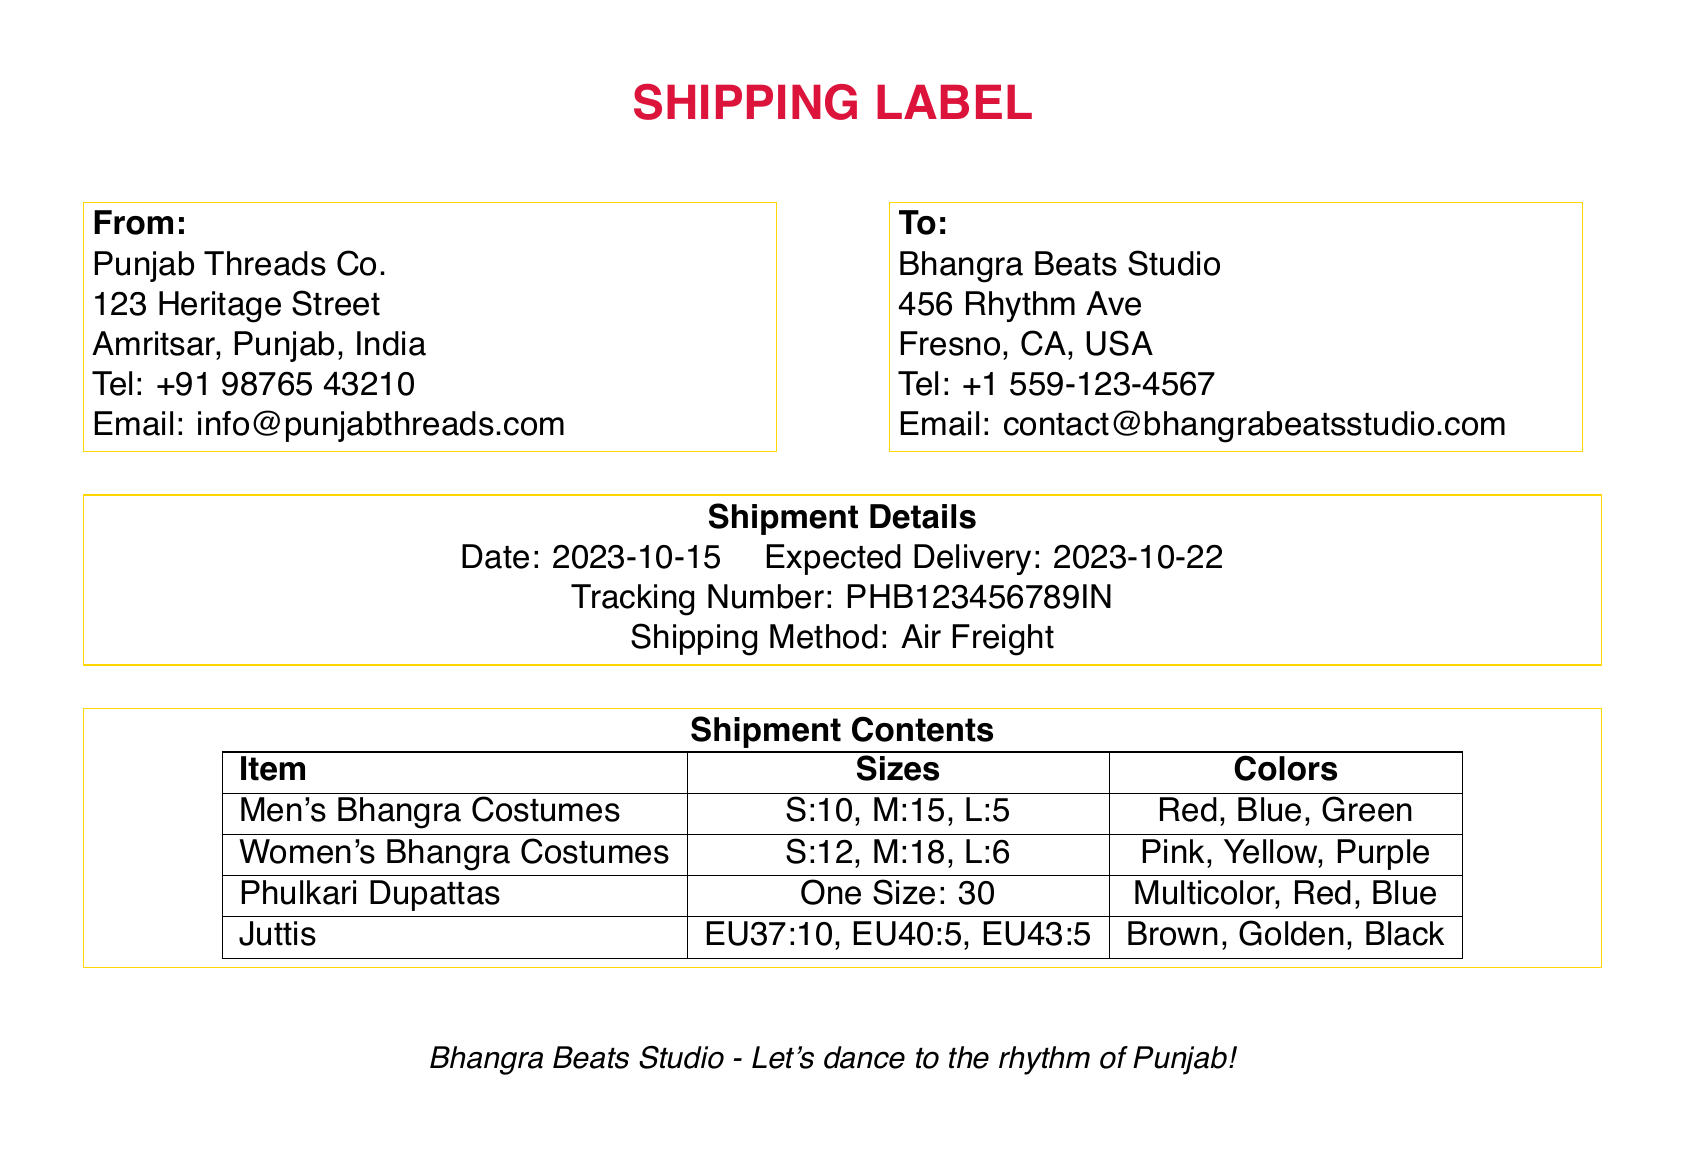what is the source of the shipment? The source of the shipment is the address listed under "From" in the document.
Answer: Punjab Threads Co what is the destination of the shipment? The destination of the shipment is the address listed under "To" in the document.
Answer: Bhangra Beats Studio what is the tracking number for this shipment? The tracking number is a unique identifier provided for tracking purposes in the shipment details section.
Answer: PHB123456789IN what shipping method is used for this shipment? The shipping method is stated in the shipment details section of the document.
Answer: Air Freight how many Men's Bhangra Costumes are in size M? The number of Men's Bhangra Costumes in size M is specified in the item breakdown.
Answer: 15 what are the colors available for Women's Bhangra Costumes? The colors available for Women's Bhangra Costumes are listed in the shipment contents table.
Answer: Pink, Yellow, Purple how many Phulkari Dupattas are included in the shipment? The total quantity of Phulkari Dupattas is found by reading the items listed in the shipment contents.
Answer: 30 what is the expected delivery date? The expected delivery date is mentioned in the shipment details section of the document.
Answer: 2023-10-22 how many Juttis are available in EU40 size? The quantity of Juttis in EU40 size is provided in the breakdown of items included.
Answer: 5 